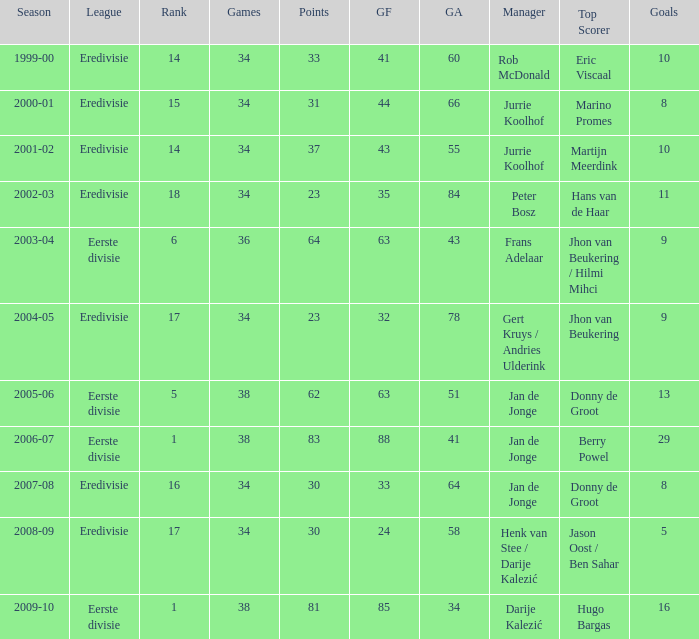Who holds the highest scoring record with 41 goals? Eric Viscaal. 